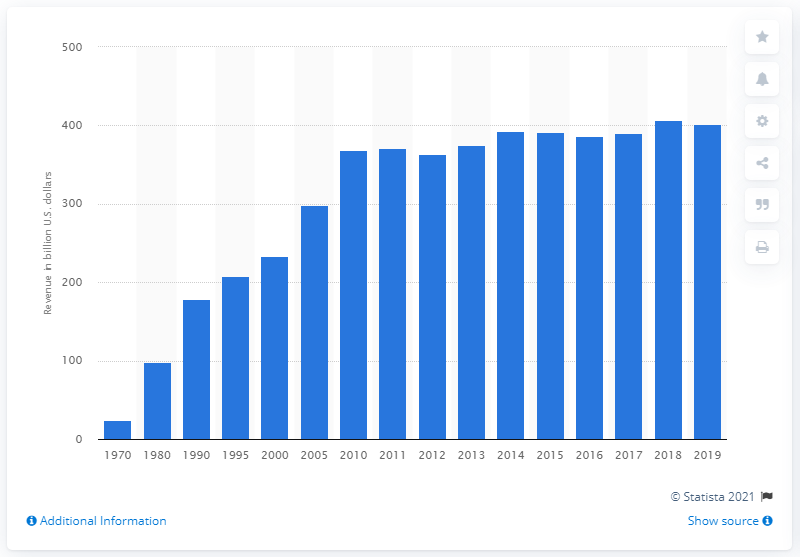Point out several critical features in this image. In 2019, the electric power industry in the United States generated a total revenue of 401.7 billion dollars. 